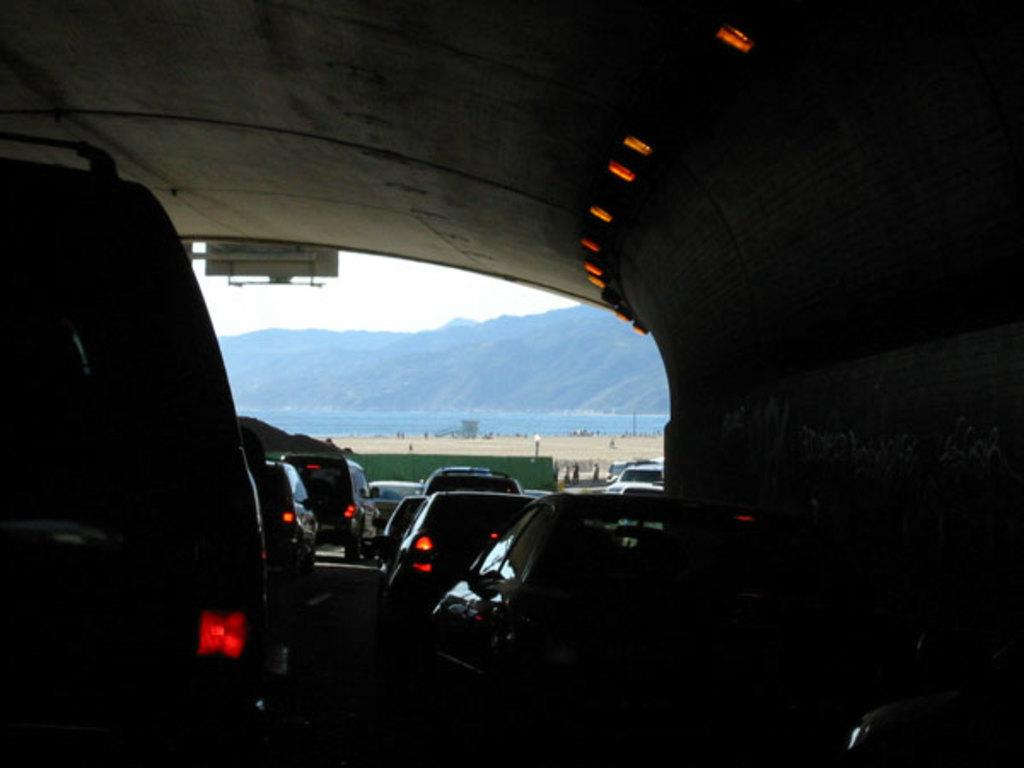What type of transportation system is depicted in the image? There is a subway in the image. What is happening in the subway? Vehicles are passing through the subway. What can be seen in the distance in the image? There are mountains in the background of the image. Where is the flower placed on the shelf in the image? There is no flower or shelf present in the image. 